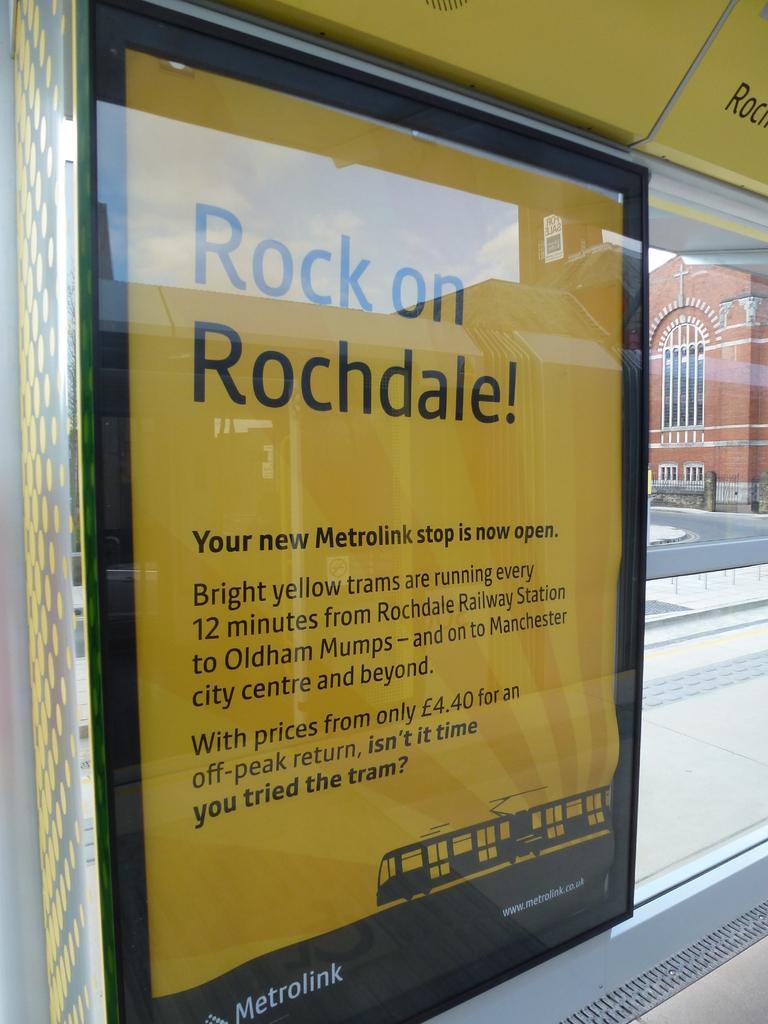Can you describe this image briefly? In this image we can see board. In the background there is building and road. 